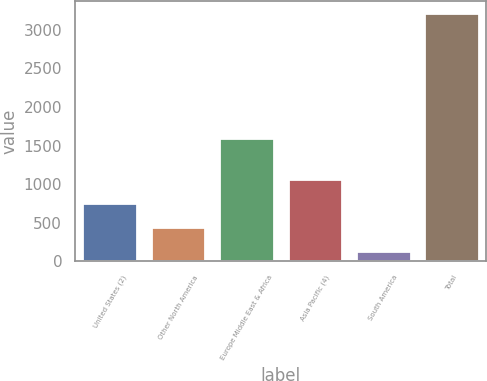<chart> <loc_0><loc_0><loc_500><loc_500><bar_chart><fcel>United States (2)<fcel>Other North America<fcel>Europe Middle East & Africa<fcel>Asia Pacific (4)<fcel>South America<fcel>Total<nl><fcel>752.8<fcel>444.9<fcel>1592<fcel>1060.7<fcel>137<fcel>3216<nl></chart> 